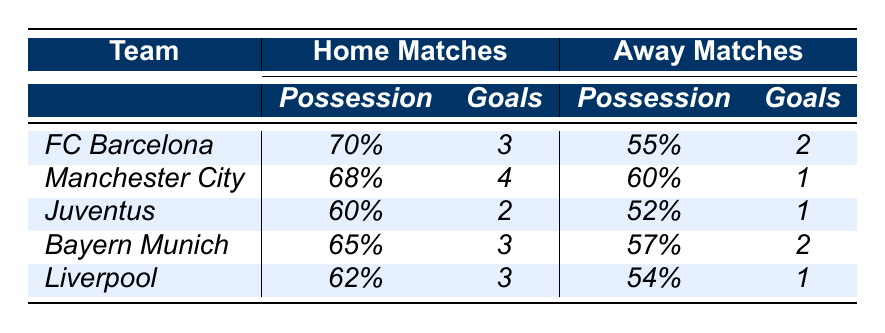What is the possession percentage of FC Barcelona in home matches? According to the table, FC Barcelona's possession in home matches is listed as 70%.
Answer: 70% How many goals did Manchester City score in away matches? The table indicates that Manchester City scored 1 goal in their away matches.
Answer: 1 Which team had the highest possession percentage in home matches? By comparing the possession percentages in home matches, FC Barcelona has the highest at 70%.
Answer: FC Barcelona What is the difference in goals scored by Juventus at home and away? Juventus scored 2 goals at home and 1 goal away. The difference is 2 - 1 = 1 goal.
Answer: 1 Did Liverpool score more goals at home or away? Liverpool scored 3 goals at home and 1 goal away. 3 is greater than 1, so they scored more at home.
Answer: Yes What is the average possession percentage of all teams in home matches? The possession percentages for home matches are 70%, 68%, 60%, 65%, and 62%. The sum is 335%, and dividing by 5 gives an average of 67%.
Answer: 67% Which team had the least shots on target in away matches? By reviewing the shots on target in away matches, Juventus had the least with 5 shots.
Answer: Juventus If we sum the goals scored by Bayern Munich in both home and away matches, what is the total? Bayern Munich scored 3 goals at home and 2 goals away. Sum is 3 + 2 = 5 goals.
Answer: 5 What is the difference in defensive actions between home and away matches for Liverpool? Liverpool had 19 defensive actions at home and 32 away, so the difference is 32 - 19 = 13 defensive actions.
Answer: 13 Which team's home matches resulted in the least number of goals scored? The table shows Juventus with 2 goals scored at home, which is the least compared to the others.
Answer: Juventus 